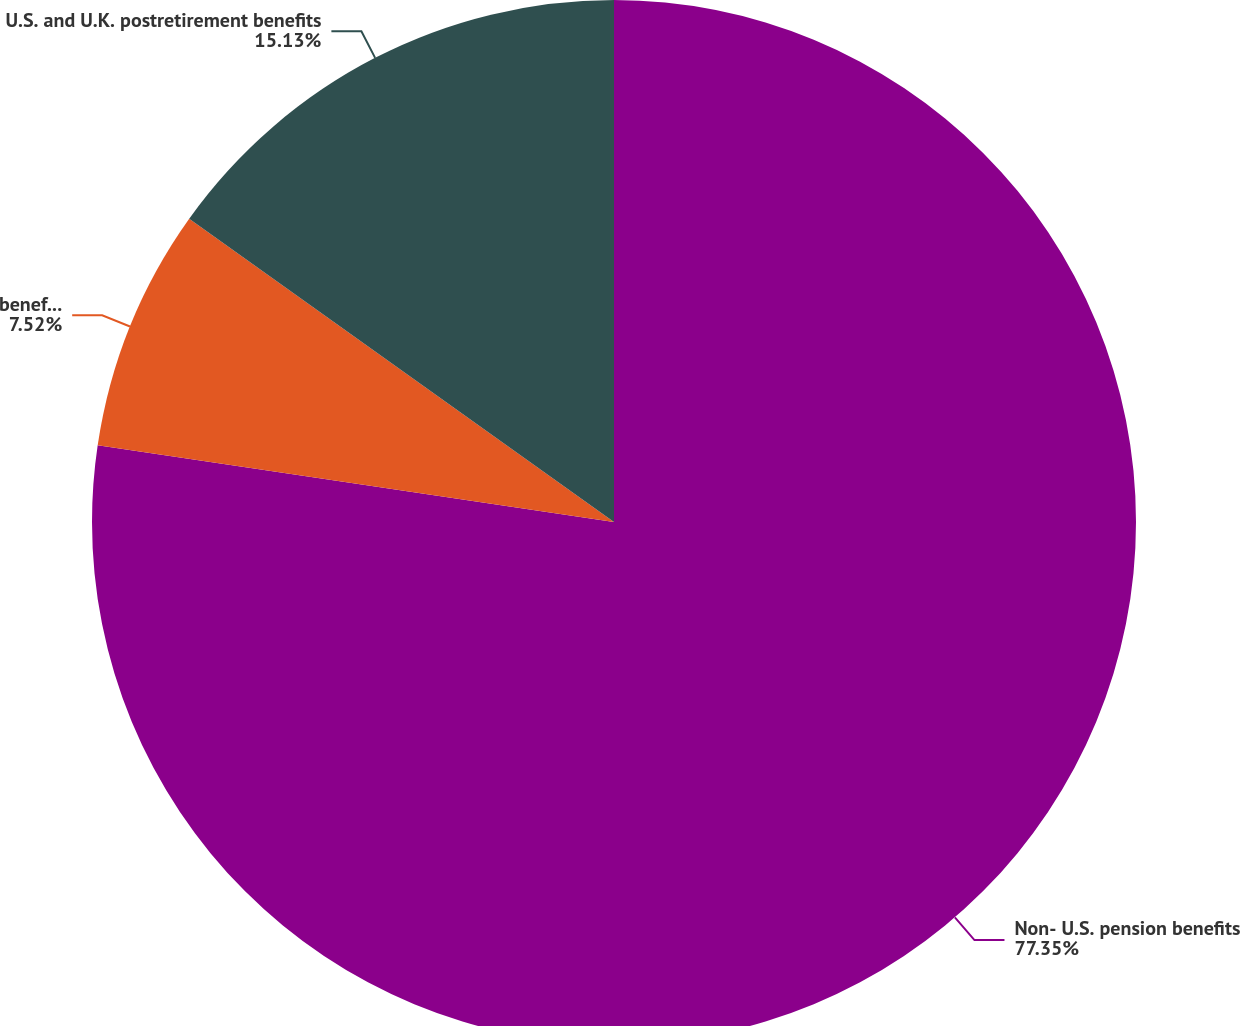Convert chart. <chart><loc_0><loc_0><loc_500><loc_500><pie_chart><fcel>Non- U.S. pension benefits<fcel>benefits<fcel>U.S. and U.K. postretirement benefits<nl><fcel>77.35%<fcel>7.52%<fcel>15.13%<nl></chart> 